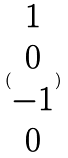<formula> <loc_0><loc_0><loc_500><loc_500>( \begin{matrix} 1 \\ 0 \\ - 1 \\ 0 \end{matrix} )</formula> 